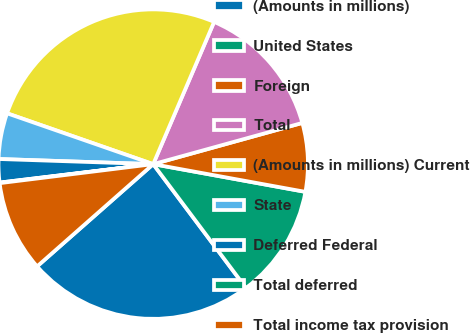Convert chart to OTSL. <chart><loc_0><loc_0><loc_500><loc_500><pie_chart><fcel>(Amounts in millions)<fcel>United States<fcel>Foreign<fcel>Total<fcel>(Amounts in millions) Current<fcel>State<fcel>Deferred Federal<fcel>Total deferred<fcel>Total income tax provision<nl><fcel>23.74%<fcel>11.9%<fcel>7.16%<fcel>14.27%<fcel>26.11%<fcel>4.8%<fcel>2.43%<fcel>0.06%<fcel>9.53%<nl></chart> 